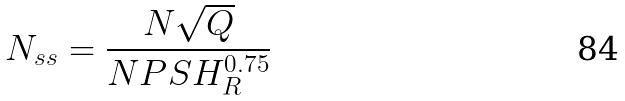Convert formula to latex. <formula><loc_0><loc_0><loc_500><loc_500>N _ { s s } = \frac { N \sqrt { Q } } { N P S H _ { R } ^ { 0 . 7 5 } }</formula> 